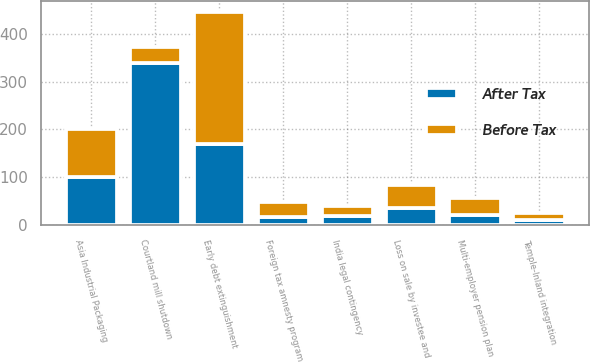Convert chart. <chart><loc_0><loc_0><loc_500><loc_500><stacked_bar_chart><ecel><fcel>Temple-Inland integration<fcel>Courtland mill shutdown<fcel>Early debt extinguishment<fcel>India legal contingency<fcel>Multi-employer pension plan<fcel>Foreign tax amnesty program<fcel>Asia Industrial Packaging<fcel>Loss on sale by investee and<nl><fcel>Before Tax<fcel>16<fcel>35<fcel>276<fcel>20<fcel>35<fcel>32<fcel>100<fcel>47<nl><fcel>After Tax<fcel>10<fcel>338<fcel>169<fcel>20<fcel>21<fcel>17<fcel>100<fcel>36<nl></chart> 